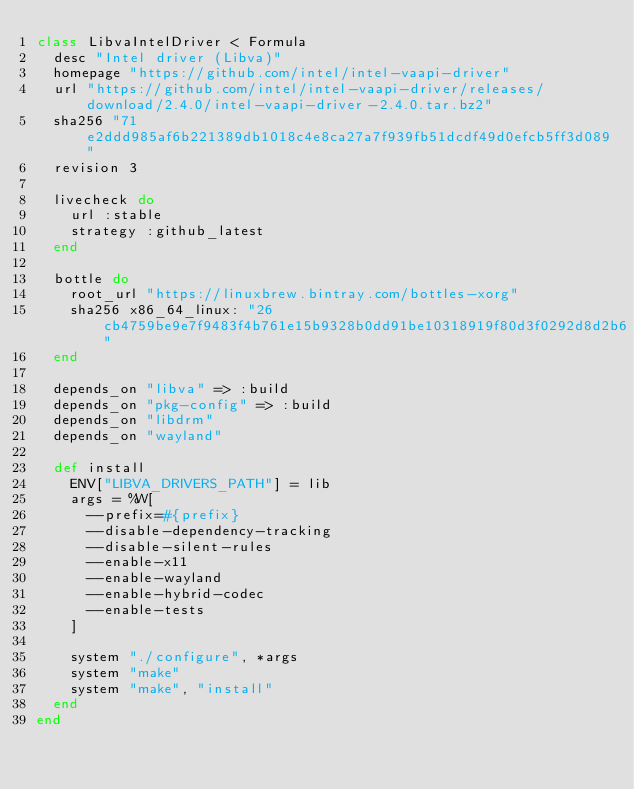Convert code to text. <code><loc_0><loc_0><loc_500><loc_500><_Ruby_>class LibvaIntelDriver < Formula
  desc "Intel driver (Libva)"
  homepage "https://github.com/intel/intel-vaapi-driver"
  url "https://github.com/intel/intel-vaapi-driver/releases/download/2.4.0/intel-vaapi-driver-2.4.0.tar.bz2"
  sha256 "71e2ddd985af6b221389db1018c4e8ca27a7f939fb51dcdf49d0efcb5ff3d089"
  revision 3

  livecheck do
    url :stable
    strategy :github_latest
  end

  bottle do
    root_url "https://linuxbrew.bintray.com/bottles-xorg"
    sha256 x86_64_linux: "26cb4759be9e7f9483f4b761e15b9328b0dd91be10318919f80d3f0292d8d2b6"
  end

  depends_on "libva" => :build
  depends_on "pkg-config" => :build
  depends_on "libdrm"
  depends_on "wayland"

  def install
    ENV["LIBVA_DRIVERS_PATH"] = lib
    args = %W[
      --prefix=#{prefix}
      --disable-dependency-tracking
      --disable-silent-rules
      --enable-x11
      --enable-wayland
      --enable-hybrid-codec
      --enable-tests
    ]

    system "./configure", *args
    system "make"
    system "make", "install"
  end
end
</code> 